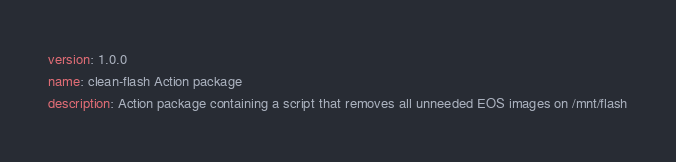Convert code to text. <code><loc_0><loc_0><loc_500><loc_500><_YAML_>version: 1.0.0
name: clean-flash Action package
description: Action package containing a script that removes all unneeded EOS images on /mnt/flash
</code> 